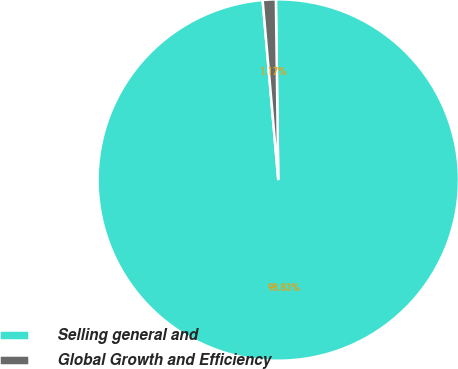Convert chart to OTSL. <chart><loc_0><loc_0><loc_500><loc_500><pie_chart><fcel>Selling general and<fcel>Global Growth and Efficiency<nl><fcel>98.83%<fcel>1.17%<nl></chart> 